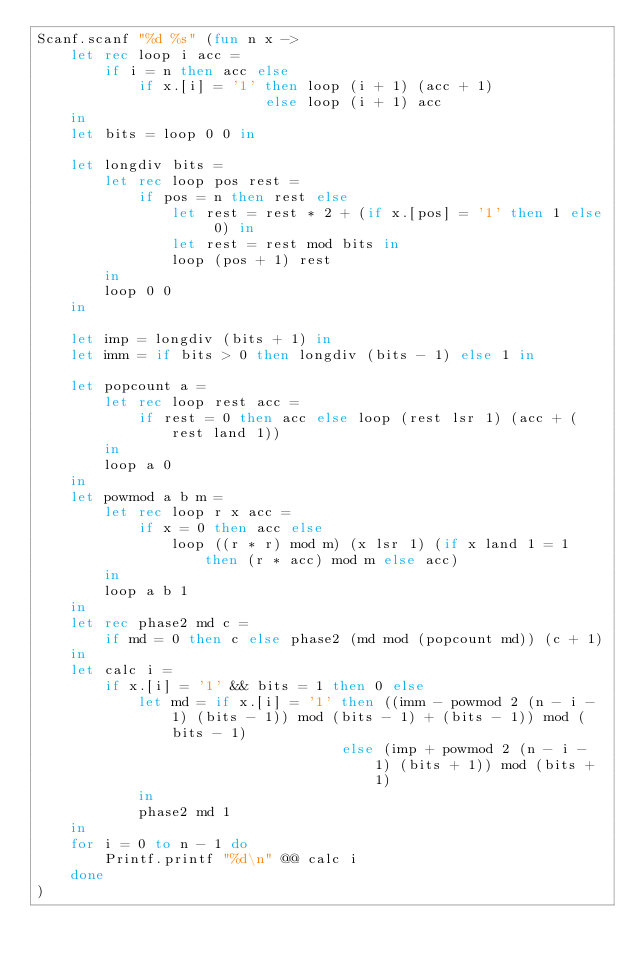<code> <loc_0><loc_0><loc_500><loc_500><_OCaml_>Scanf.scanf "%d %s" (fun n x ->
    let rec loop i acc =
        if i = n then acc else
            if x.[i] = '1' then loop (i + 1) (acc + 1)
                           else loop (i + 1) acc
    in
    let bits = loop 0 0 in

    let longdiv bits =
        let rec loop pos rest =
            if pos = n then rest else
                let rest = rest * 2 + (if x.[pos] = '1' then 1 else 0) in
                let rest = rest mod bits in
                loop (pos + 1) rest
        in
        loop 0 0
    in

    let imp = longdiv (bits + 1) in
    let imm = if bits > 0 then longdiv (bits - 1) else 1 in

    let popcount a =
        let rec loop rest acc =
            if rest = 0 then acc else loop (rest lsr 1) (acc + (rest land 1))
        in
        loop a 0
    in
    let powmod a b m =
        let rec loop r x acc =
            if x = 0 then acc else
                loop ((r * r) mod m) (x lsr 1) (if x land 1 = 1 then (r * acc) mod m else acc)
        in
        loop a b 1
    in
    let rec phase2 md c =
        if md = 0 then c else phase2 (md mod (popcount md)) (c + 1)
    in
    let calc i =
        if x.[i] = '1' && bits = 1 then 0 else
            let md = if x.[i] = '1' then ((imm - powmod 2 (n - i - 1) (bits - 1)) mod (bits - 1) + (bits - 1)) mod (bits - 1)
                                    else (imp + powmod 2 (n - i - 1) (bits + 1)) mod (bits + 1)
            in
            phase2 md 1
    in
    for i = 0 to n - 1 do
        Printf.printf "%d\n" @@ calc i
    done
)</code> 